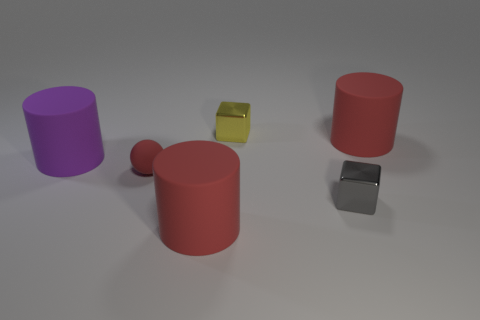Are there any large purple matte cylinders that are behind the big red cylinder in front of the gray cube?
Give a very brief answer. Yes. How many purple matte things have the same size as the red ball?
Ensure brevity in your answer.  0. How many small red rubber objects are to the right of the small thing that is left of the big red thing that is in front of the purple matte object?
Keep it short and to the point. 0. How many rubber cylinders are right of the big purple matte thing and behind the gray metal thing?
Your answer should be very brief. 1. Is there anything else that is the same color as the tiny matte ball?
Your response must be concise. Yes. How many matte things are red balls or purple cylinders?
Ensure brevity in your answer.  2. There is a big red thing to the left of the red object right of the big red rubber cylinder in front of the red ball; what is it made of?
Your answer should be very brief. Rubber. There is a tiny thing in front of the tiny matte ball on the left side of the small yellow metal cube; what is its material?
Your response must be concise. Metal. Is the size of the red cylinder that is in front of the purple thing the same as the red object that is right of the tiny yellow block?
Provide a succinct answer. Yes. How many big objects are blue rubber cylinders or gray metal cubes?
Your answer should be compact. 0. 